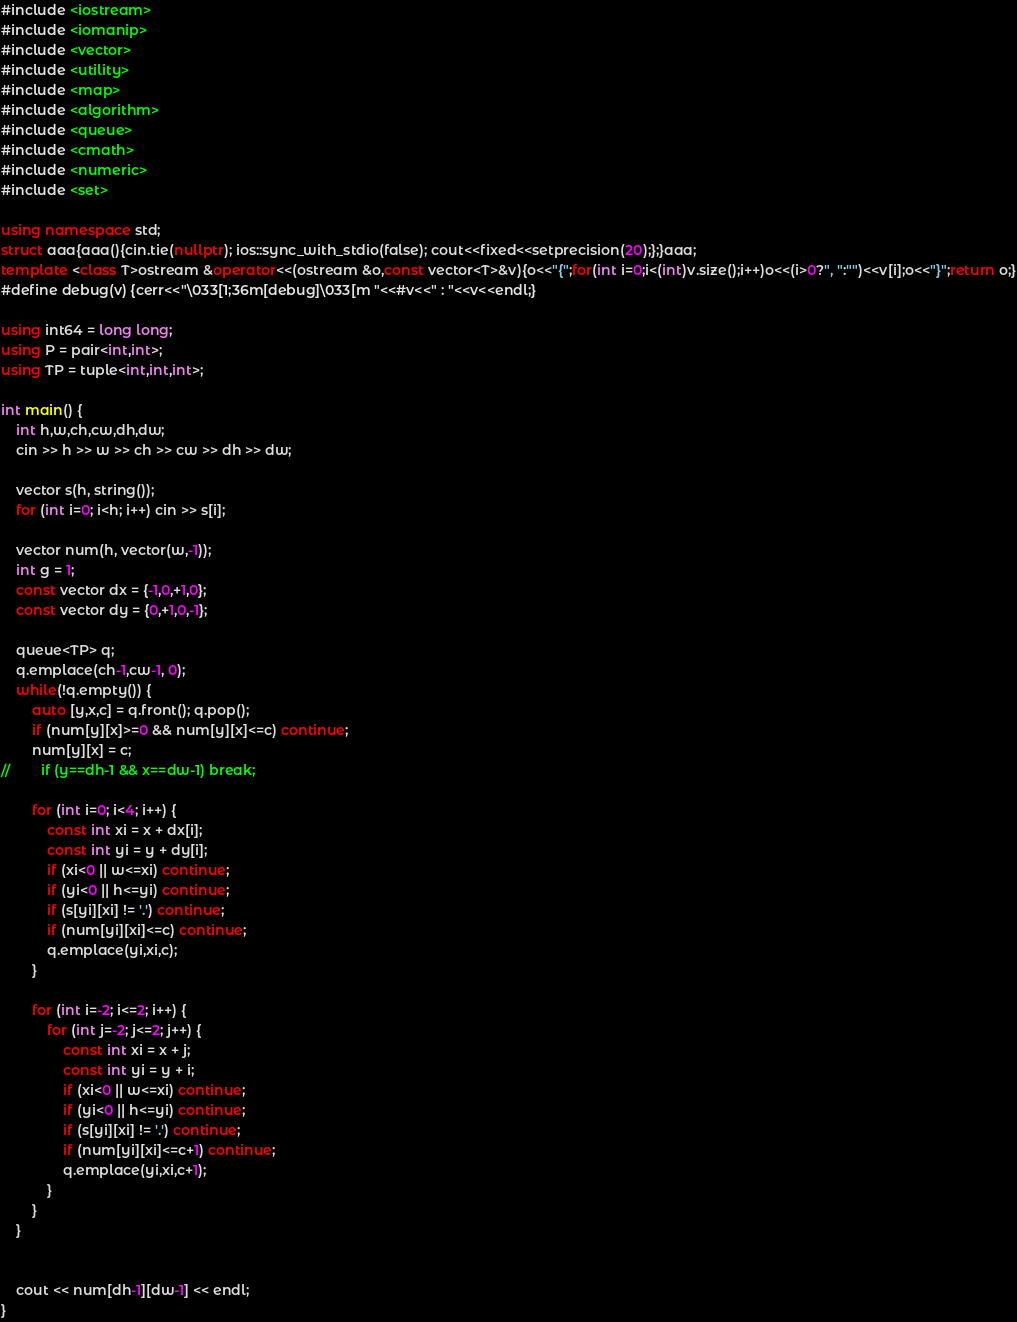Convert code to text. <code><loc_0><loc_0><loc_500><loc_500><_C++_>#include <iostream>
#include <iomanip>
#include <vector>
#include <utility>
#include <map>
#include <algorithm>
#include <queue>
#include <cmath>
#include <numeric>
#include <set>

using namespace std;
struct aaa{aaa(){cin.tie(nullptr); ios::sync_with_stdio(false); cout<<fixed<<setprecision(20);};}aaa;
template <class T>ostream &operator<<(ostream &o,const vector<T>&v){o<<"{";for(int i=0;i<(int)v.size();i++)o<<(i>0?", ":"")<<v[i];o<<"}";return o;}
#define debug(v) {cerr<<"\033[1;36m[debug]\033[m "<<#v<<" : "<<v<<endl;}

using int64 = long long;
using P = pair<int,int>;
using TP = tuple<int,int,int>;

int main() {
    int h,w,ch,cw,dh,dw;
    cin >> h >> w >> ch >> cw >> dh >> dw;

    vector s(h, string());
    for (int i=0; i<h; i++) cin >> s[i];

    vector num(h, vector(w,-1));
    int g = 1;
    const vector dx = {-1,0,+1,0};
    const vector dy = {0,+1,0,-1};

    queue<TP> q;
    q.emplace(ch-1,cw-1, 0);
    while(!q.empty()) {
        auto [y,x,c] = q.front(); q.pop();
        if (num[y][x]>=0 && num[y][x]<=c) continue;
        num[y][x] = c;
//        if (y==dh-1 && x==dw-1) break;

        for (int i=0; i<4; i++) {
            const int xi = x + dx[i];
            const int yi = y + dy[i];
            if (xi<0 || w<=xi) continue;
            if (yi<0 || h<=yi) continue;
            if (s[yi][xi] != '.') continue;
            if (num[yi][xi]<=c) continue;
            q.emplace(yi,xi,c);
        }

        for (int i=-2; i<=2; i++) {
            for (int j=-2; j<=2; j++) {
                const int xi = x + j;
                const int yi = y + i;
                if (xi<0 || w<=xi) continue;
                if (yi<0 || h<=yi) continue;
                if (s[yi][xi] != '.') continue;
                if (num[yi][xi]<=c+1) continue;
                q.emplace(yi,xi,c+1);
            }
        }
    }


    cout << num[dh-1][dw-1] << endl;
}</code> 